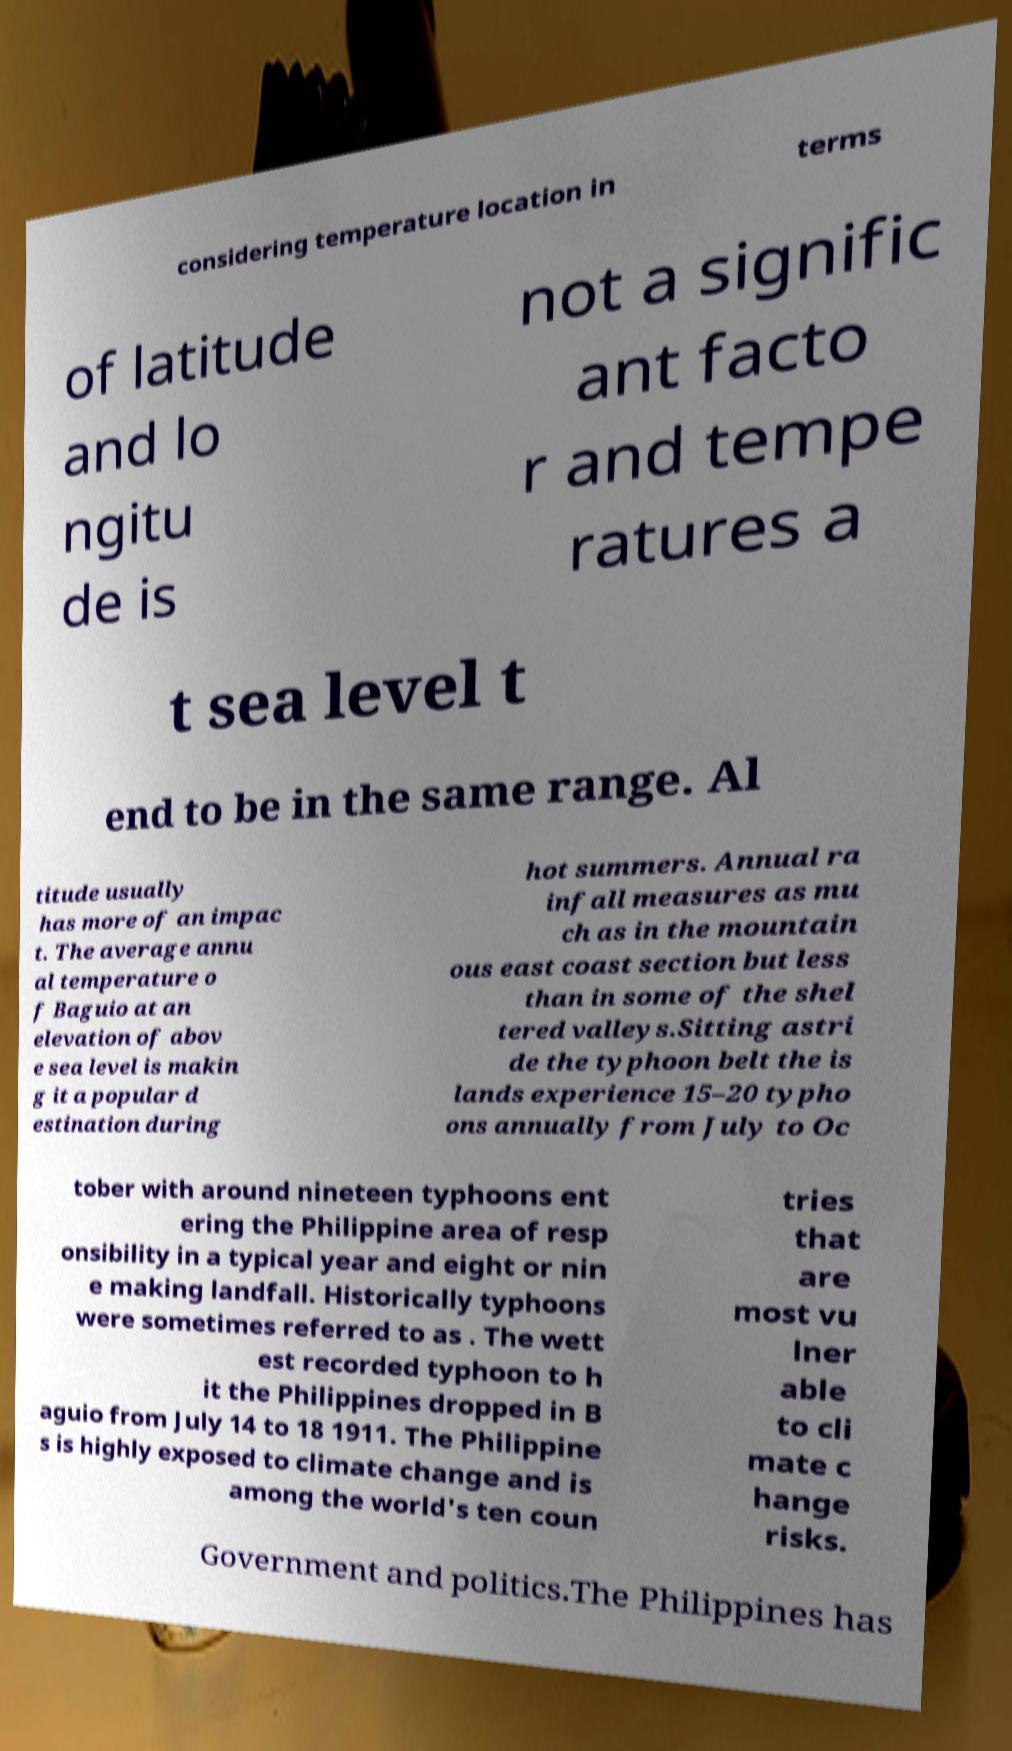Can you accurately transcribe the text from the provided image for me? considering temperature location in terms of latitude and lo ngitu de is not a signific ant facto r and tempe ratures a t sea level t end to be in the same range. Al titude usually has more of an impac t. The average annu al temperature o f Baguio at an elevation of abov e sea level is makin g it a popular d estination during hot summers. Annual ra infall measures as mu ch as in the mountain ous east coast section but less than in some of the shel tered valleys.Sitting astri de the typhoon belt the is lands experience 15–20 typho ons annually from July to Oc tober with around nineteen typhoons ent ering the Philippine area of resp onsibility in a typical year and eight or nin e making landfall. Historically typhoons were sometimes referred to as . The wett est recorded typhoon to h it the Philippines dropped in B aguio from July 14 to 18 1911. The Philippine s is highly exposed to climate change and is among the world's ten coun tries that are most vu lner able to cli mate c hange risks. Government and politics.The Philippines has 